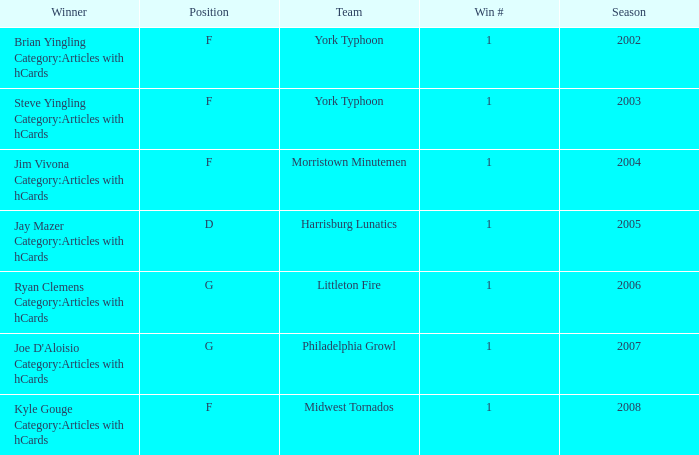Who was the winner in the 2008 season? Kyle Gouge Category:Articles with hCards. 